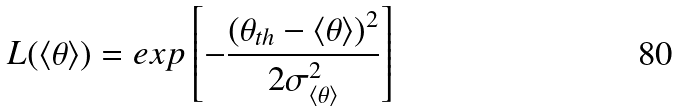Convert formula to latex. <formula><loc_0><loc_0><loc_500><loc_500>L ( \langle \theta \rangle ) = e x p \left [ - \frac { ( \theta _ { t h } - \langle \theta \rangle ) ^ { 2 } } { 2 \sigma _ { \langle \theta \rangle } ^ { 2 } } \right ]</formula> 